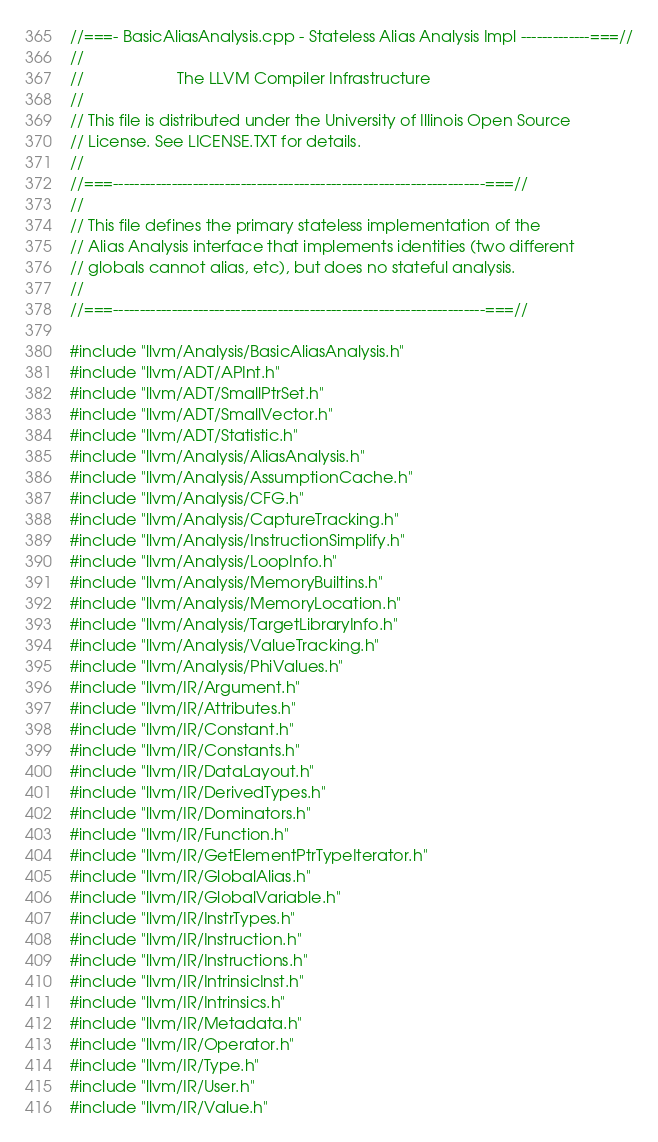<code> <loc_0><loc_0><loc_500><loc_500><_C++_>//===- BasicAliasAnalysis.cpp - Stateless Alias Analysis Impl -------------===//
//
//                     The LLVM Compiler Infrastructure
//
// This file is distributed under the University of Illinois Open Source
// License. See LICENSE.TXT for details.
//
//===----------------------------------------------------------------------===//
//
// This file defines the primary stateless implementation of the
// Alias Analysis interface that implements identities (two different
// globals cannot alias, etc), but does no stateful analysis.
//
//===----------------------------------------------------------------------===//

#include "llvm/Analysis/BasicAliasAnalysis.h"
#include "llvm/ADT/APInt.h"
#include "llvm/ADT/SmallPtrSet.h"
#include "llvm/ADT/SmallVector.h"
#include "llvm/ADT/Statistic.h"
#include "llvm/Analysis/AliasAnalysis.h"
#include "llvm/Analysis/AssumptionCache.h"
#include "llvm/Analysis/CFG.h"
#include "llvm/Analysis/CaptureTracking.h"
#include "llvm/Analysis/InstructionSimplify.h"
#include "llvm/Analysis/LoopInfo.h"
#include "llvm/Analysis/MemoryBuiltins.h"
#include "llvm/Analysis/MemoryLocation.h"
#include "llvm/Analysis/TargetLibraryInfo.h"
#include "llvm/Analysis/ValueTracking.h"
#include "llvm/Analysis/PhiValues.h"
#include "llvm/IR/Argument.h"
#include "llvm/IR/Attributes.h"
#include "llvm/IR/Constant.h"
#include "llvm/IR/Constants.h"
#include "llvm/IR/DataLayout.h"
#include "llvm/IR/DerivedTypes.h"
#include "llvm/IR/Dominators.h"
#include "llvm/IR/Function.h"
#include "llvm/IR/GetElementPtrTypeIterator.h"
#include "llvm/IR/GlobalAlias.h"
#include "llvm/IR/GlobalVariable.h"
#include "llvm/IR/InstrTypes.h"
#include "llvm/IR/Instruction.h"
#include "llvm/IR/Instructions.h"
#include "llvm/IR/IntrinsicInst.h"
#include "llvm/IR/Intrinsics.h"
#include "llvm/IR/Metadata.h"
#include "llvm/IR/Operator.h"
#include "llvm/IR/Type.h"
#include "llvm/IR/User.h"
#include "llvm/IR/Value.h"</code> 